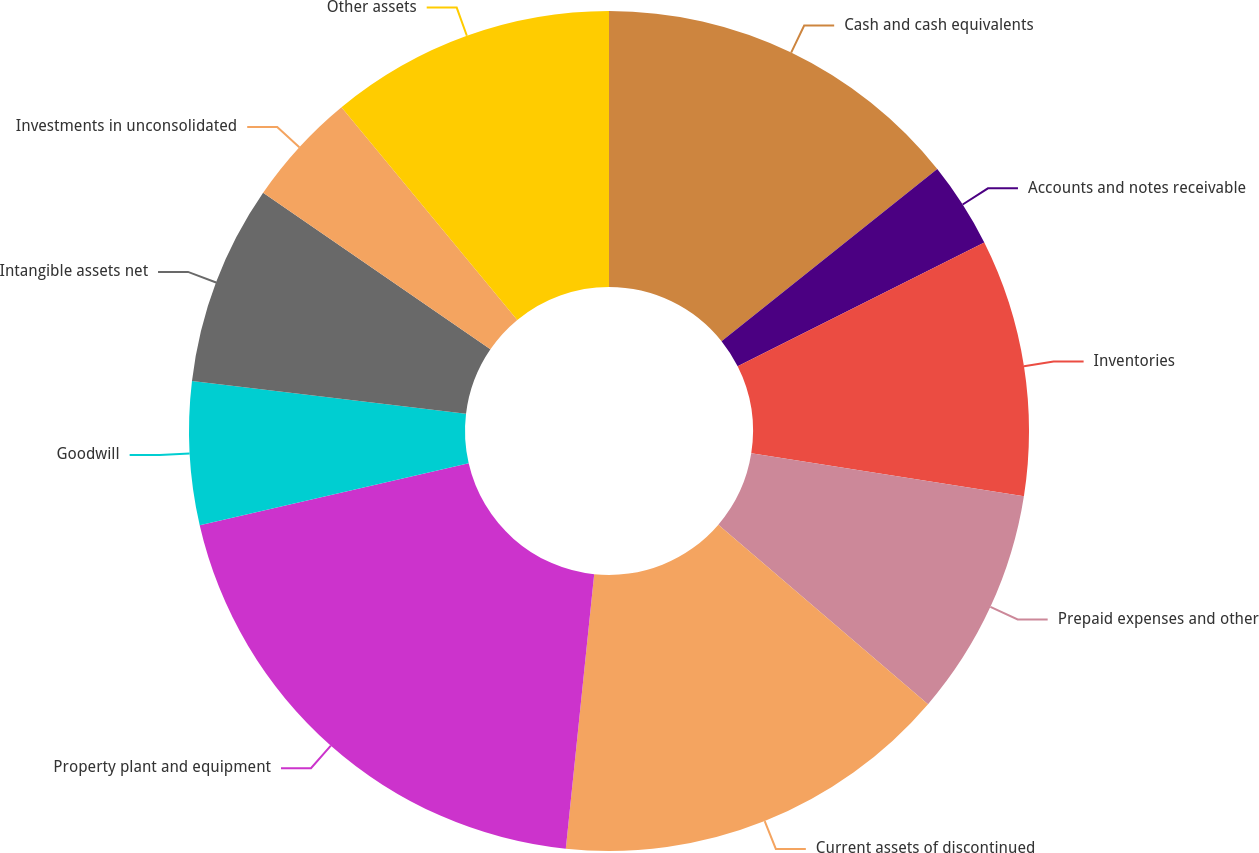Convert chart to OTSL. <chart><loc_0><loc_0><loc_500><loc_500><pie_chart><fcel>Cash and cash equivalents<fcel>Accounts and notes receivable<fcel>Inventories<fcel>Prepaid expenses and other<fcel>Current assets of discontinued<fcel>Property plant and equipment<fcel>Goodwill<fcel>Intangible assets net<fcel>Investments in unconsolidated<fcel>Other assets<nl><fcel>14.28%<fcel>3.31%<fcel>9.89%<fcel>8.79%<fcel>15.37%<fcel>19.76%<fcel>5.5%<fcel>7.7%<fcel>4.41%<fcel>10.99%<nl></chart> 